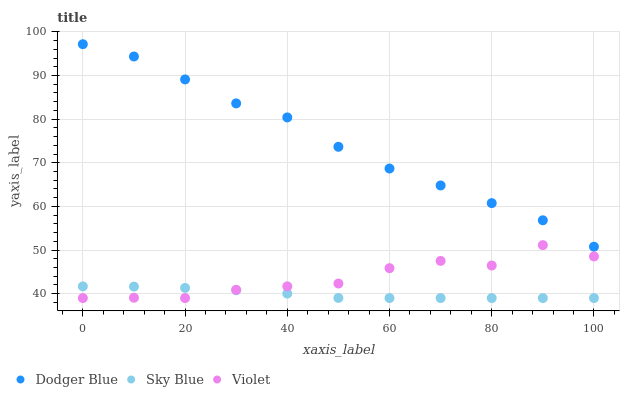Does Sky Blue have the minimum area under the curve?
Answer yes or no. Yes. Does Dodger Blue have the maximum area under the curve?
Answer yes or no. Yes. Does Violet have the minimum area under the curve?
Answer yes or no. No. Does Violet have the maximum area under the curve?
Answer yes or no. No. Is Sky Blue the smoothest?
Answer yes or no. Yes. Is Violet the roughest?
Answer yes or no. Yes. Is Dodger Blue the smoothest?
Answer yes or no. No. Is Dodger Blue the roughest?
Answer yes or no. No. Does Sky Blue have the lowest value?
Answer yes or no. Yes. Does Dodger Blue have the lowest value?
Answer yes or no. No. Does Dodger Blue have the highest value?
Answer yes or no. Yes. Does Violet have the highest value?
Answer yes or no. No. Is Violet less than Dodger Blue?
Answer yes or no. Yes. Is Dodger Blue greater than Sky Blue?
Answer yes or no. Yes. Does Sky Blue intersect Violet?
Answer yes or no. Yes. Is Sky Blue less than Violet?
Answer yes or no. No. Is Sky Blue greater than Violet?
Answer yes or no. No. Does Violet intersect Dodger Blue?
Answer yes or no. No. 